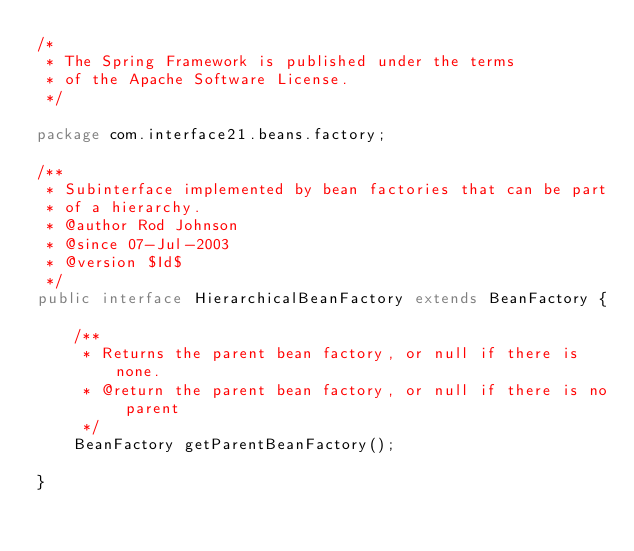<code> <loc_0><loc_0><loc_500><loc_500><_Java_>/*
 * The Spring Framework is published under the terms
 * of the Apache Software License.
 */
 
package com.interface21.beans.factory;

/**
 * Subinterface implemented by bean factories that can be part
 * of a hierarchy.
 * @author Rod Johnson
 * @since 07-Jul-2003
 * @version $Id$
 */
public interface HierarchicalBeanFactory extends BeanFactory {
	
	/**
	 * Returns the parent bean factory, or null if there is none.
	 * @return the parent bean factory, or null if there is no parent
	 */
	BeanFactory getParentBeanFactory();

}
</code> 